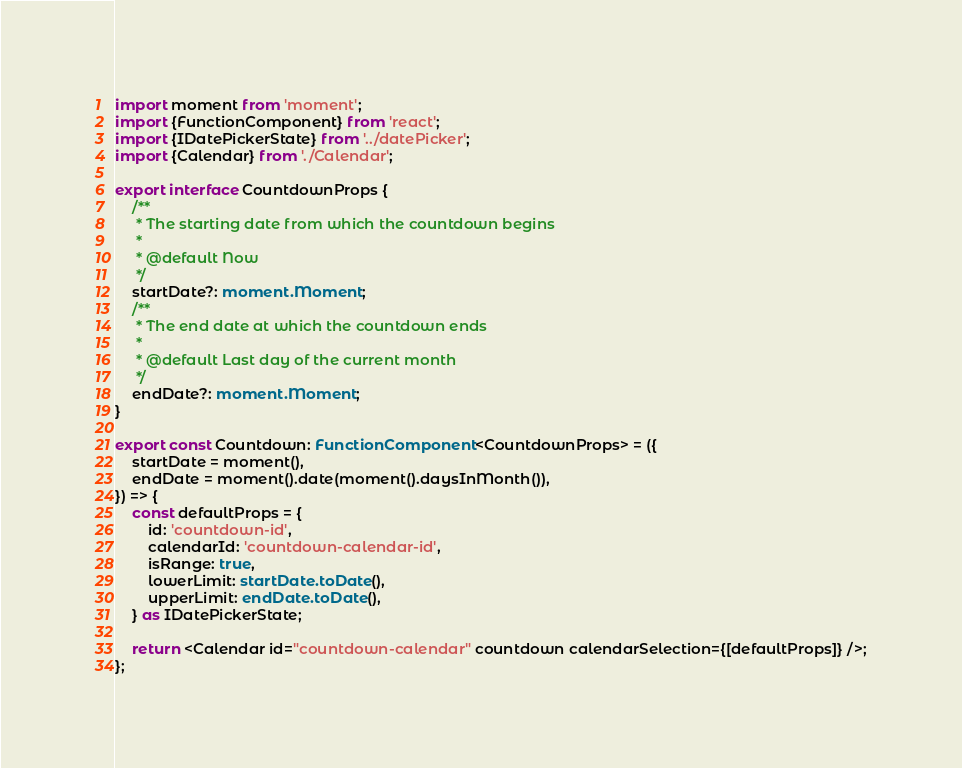Convert code to text. <code><loc_0><loc_0><loc_500><loc_500><_TypeScript_>import moment from 'moment';
import {FunctionComponent} from 'react';
import {IDatePickerState} from '../datePicker';
import {Calendar} from './Calendar';

export interface CountdownProps {
    /**
     * The starting date from which the countdown begins
     *
     * @default Now
     */
    startDate?: moment.Moment;
    /**
     * The end date at which the countdown ends
     *
     * @default Last day of the current month
     */
    endDate?: moment.Moment;
}

export const Countdown: FunctionComponent<CountdownProps> = ({
    startDate = moment(),
    endDate = moment().date(moment().daysInMonth()),
}) => {
    const defaultProps = {
        id: 'countdown-id',
        calendarId: 'countdown-calendar-id',
        isRange: true,
        lowerLimit: startDate.toDate(),
        upperLimit: endDate.toDate(),
    } as IDatePickerState;

    return <Calendar id="countdown-calendar" countdown calendarSelection={[defaultProps]} />;
};
</code> 